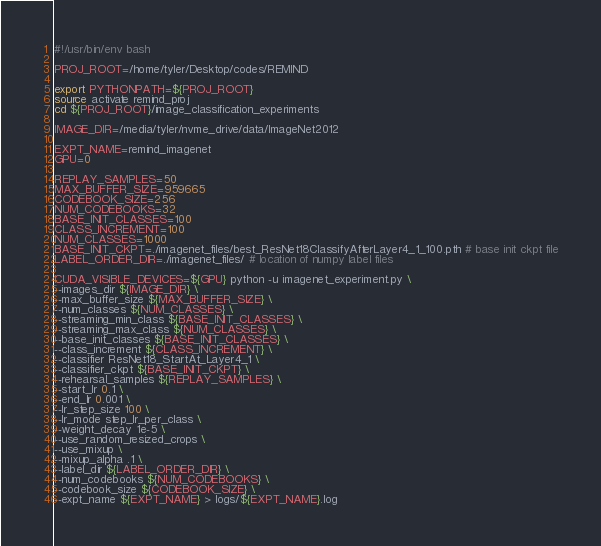<code> <loc_0><loc_0><loc_500><loc_500><_Bash_>#!/usr/bin/env bash

PROJ_ROOT=/home/tyler/Desktop/codes/REMIND

export PYTHONPATH=${PROJ_ROOT}
source activate remind_proj
cd ${PROJ_ROOT}/image_classification_experiments

IMAGE_DIR=/media/tyler/nvme_drive/data/ImageNet2012

EXPT_NAME=remind_imagenet
GPU=0

REPLAY_SAMPLES=50
MAX_BUFFER_SIZE=959665
CODEBOOK_SIZE=256
NUM_CODEBOOKS=32
BASE_INIT_CLASSES=100
CLASS_INCREMENT=100
NUM_CLASSES=1000
BASE_INIT_CKPT=./imagenet_files/best_ResNet18ClassifyAfterLayer4_1_100.pth # base init ckpt file
LABEL_ORDER_DIR=./imagenet_files/ # location of numpy label files

CUDA_VISIBLE_DEVICES=${GPU} python -u imagenet_experiment.py \
--images_dir ${IMAGE_DIR} \
--max_buffer_size ${MAX_BUFFER_SIZE} \
--num_classes ${NUM_CLASSES} \
--streaming_min_class ${BASE_INIT_CLASSES} \
--streaming_max_class ${NUM_CLASSES} \
--base_init_classes ${BASE_INIT_CLASSES} \
--class_increment ${CLASS_INCREMENT} \
--classifier ResNet18_StartAt_Layer4_1 \
--classifier_ckpt ${BASE_INIT_CKPT} \
--rehearsal_samples ${REPLAY_SAMPLES} \
--start_lr 0.1 \
--end_lr 0.001 \
--lr_step_size 100 \
--lr_mode step_lr_per_class \
--weight_decay 1e-5 \
--use_random_resized_crops \
--use_mixup \
--mixup_alpha .1 \
--label_dir ${LABEL_ORDER_DIR} \
--num_codebooks ${NUM_CODEBOOKS} \
--codebook_size ${CODEBOOK_SIZE} \
--expt_name ${EXPT_NAME} > logs/${EXPT_NAME}.log
</code> 